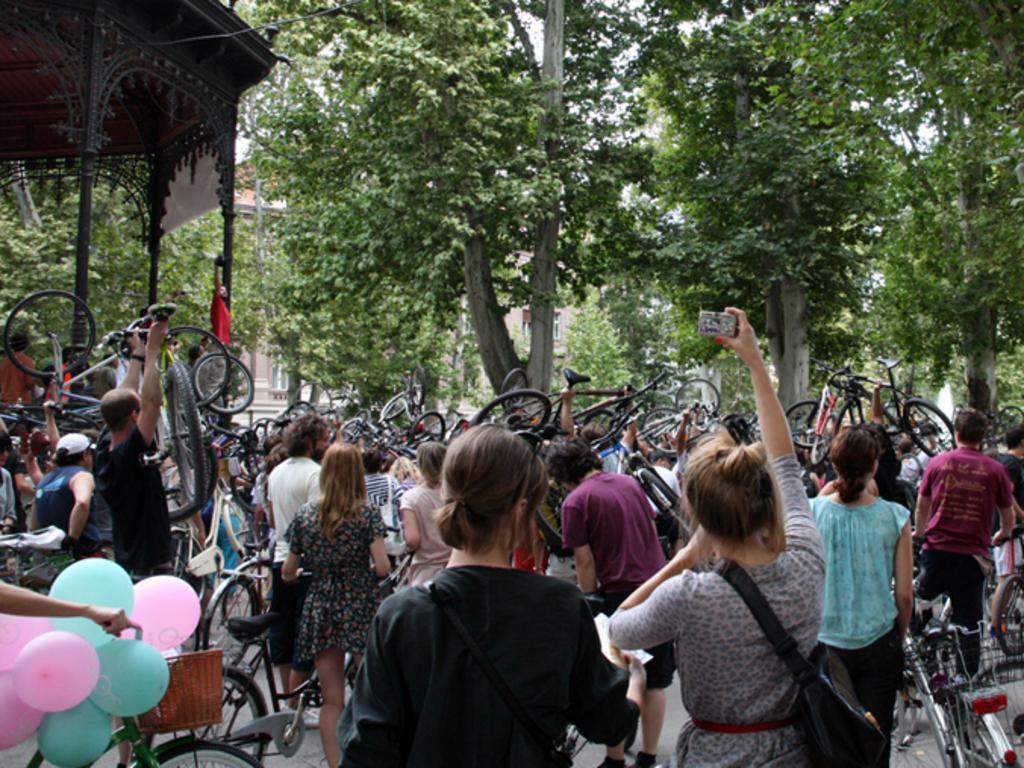How would you summarize this image in a sentence or two? In this picture we can observe some people standing. Some of them are lifting bicycles with their hands. There are men and women in this picture. On the left side we can observe blue and pink color balloons. In the background there are trees, building and a sky. 